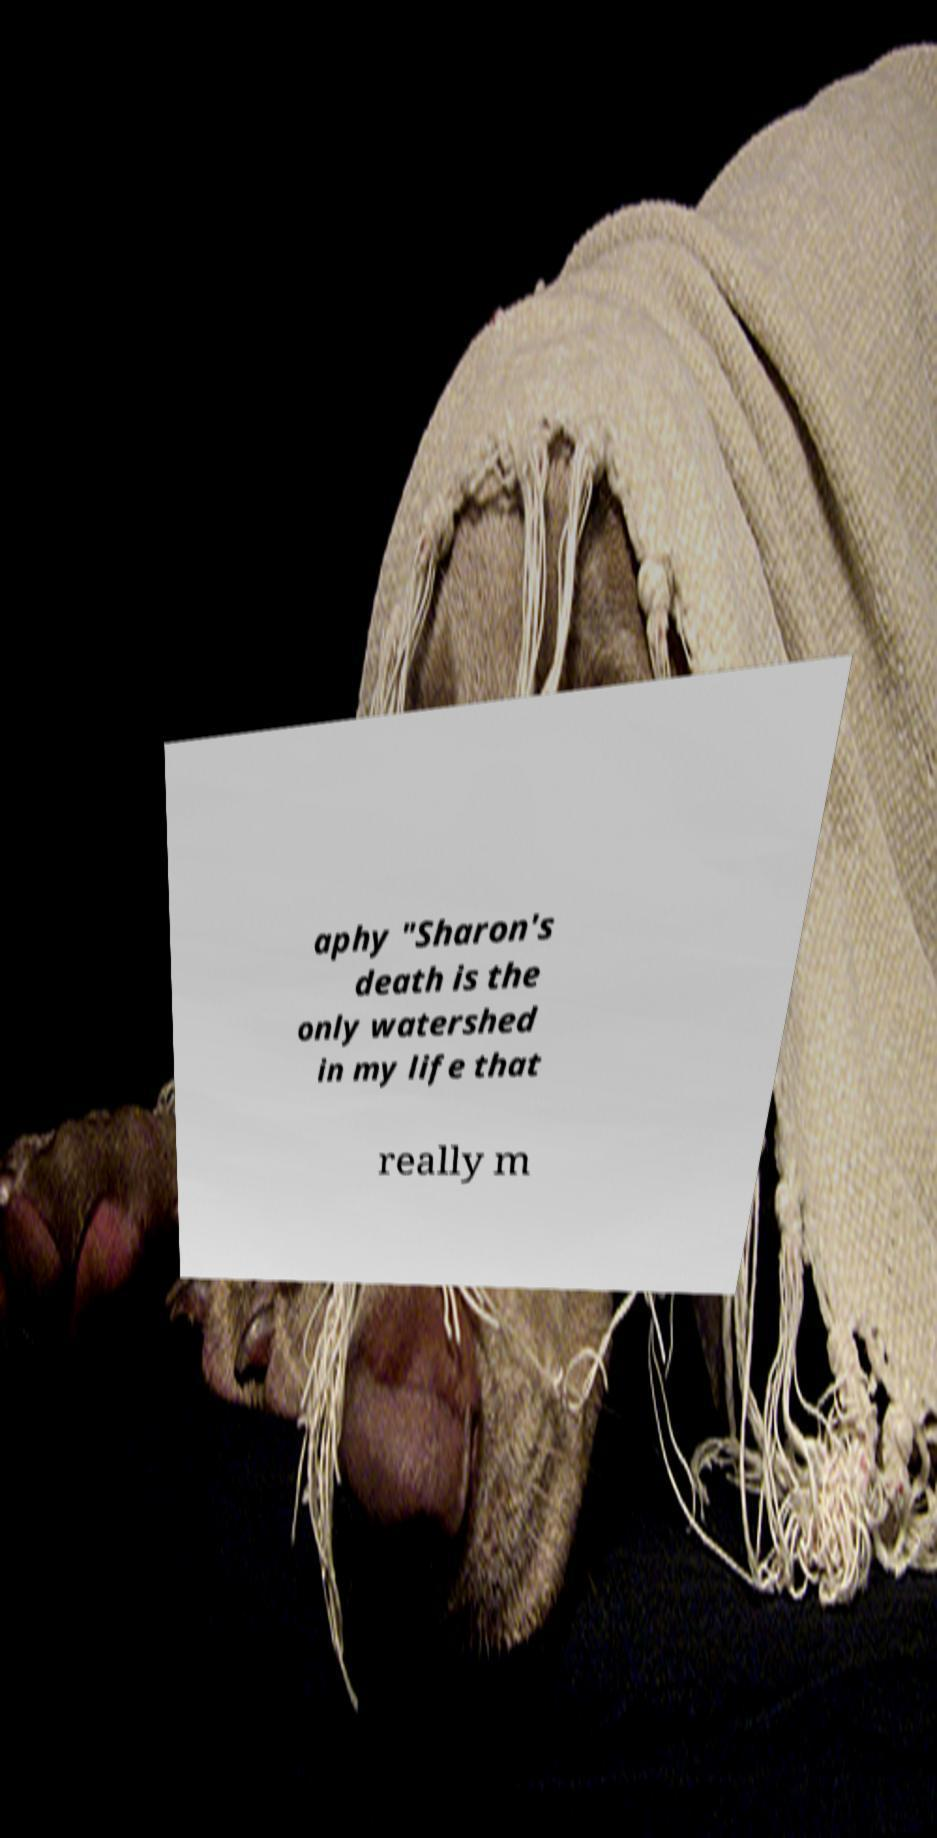For documentation purposes, I need the text within this image transcribed. Could you provide that? aphy "Sharon's death is the only watershed in my life that really m 